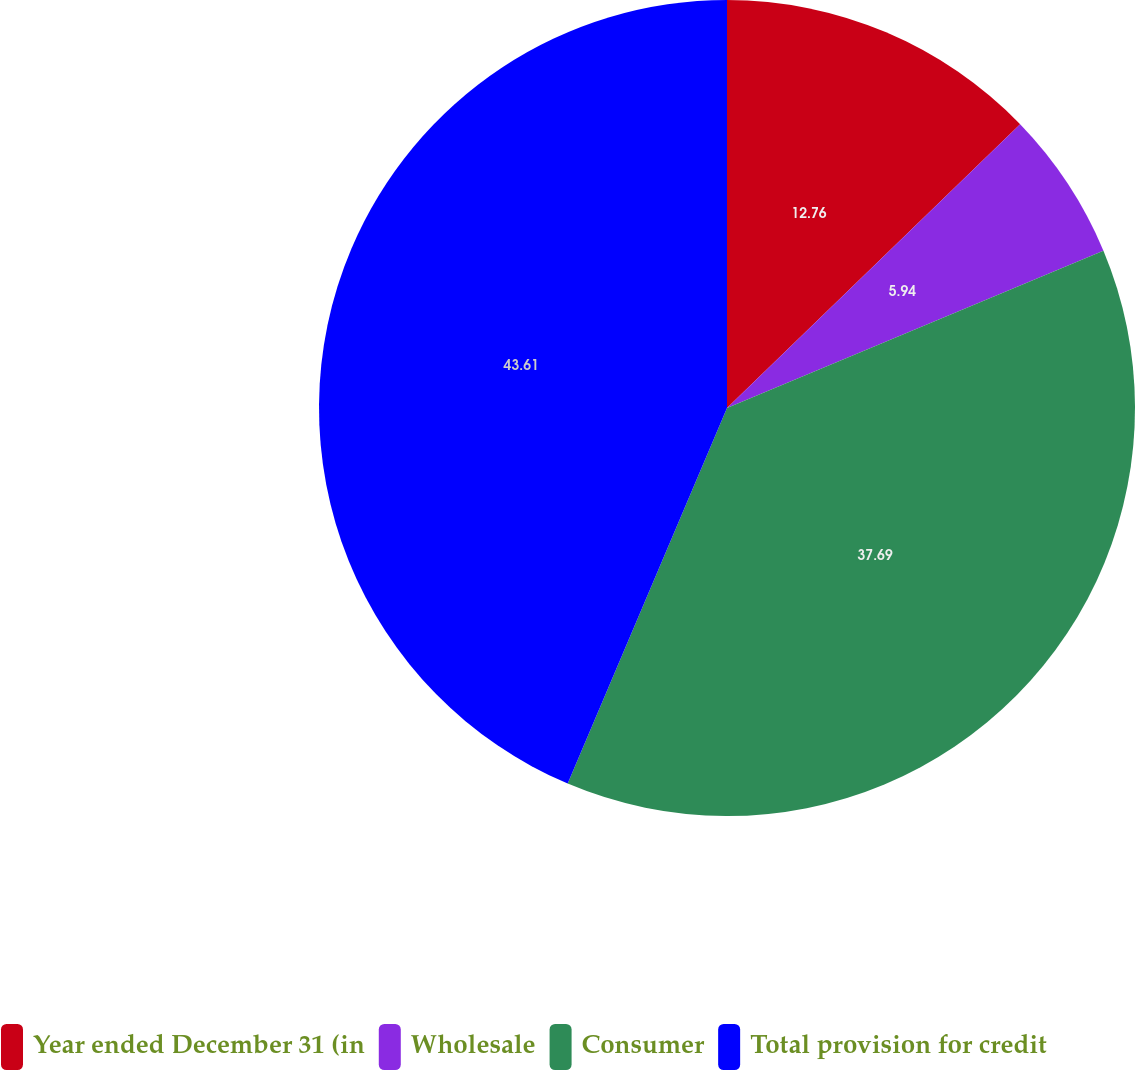Convert chart to OTSL. <chart><loc_0><loc_0><loc_500><loc_500><pie_chart><fcel>Year ended December 31 (in<fcel>Wholesale<fcel>Consumer<fcel>Total provision for credit<nl><fcel>12.76%<fcel>5.94%<fcel>37.69%<fcel>43.62%<nl></chart> 